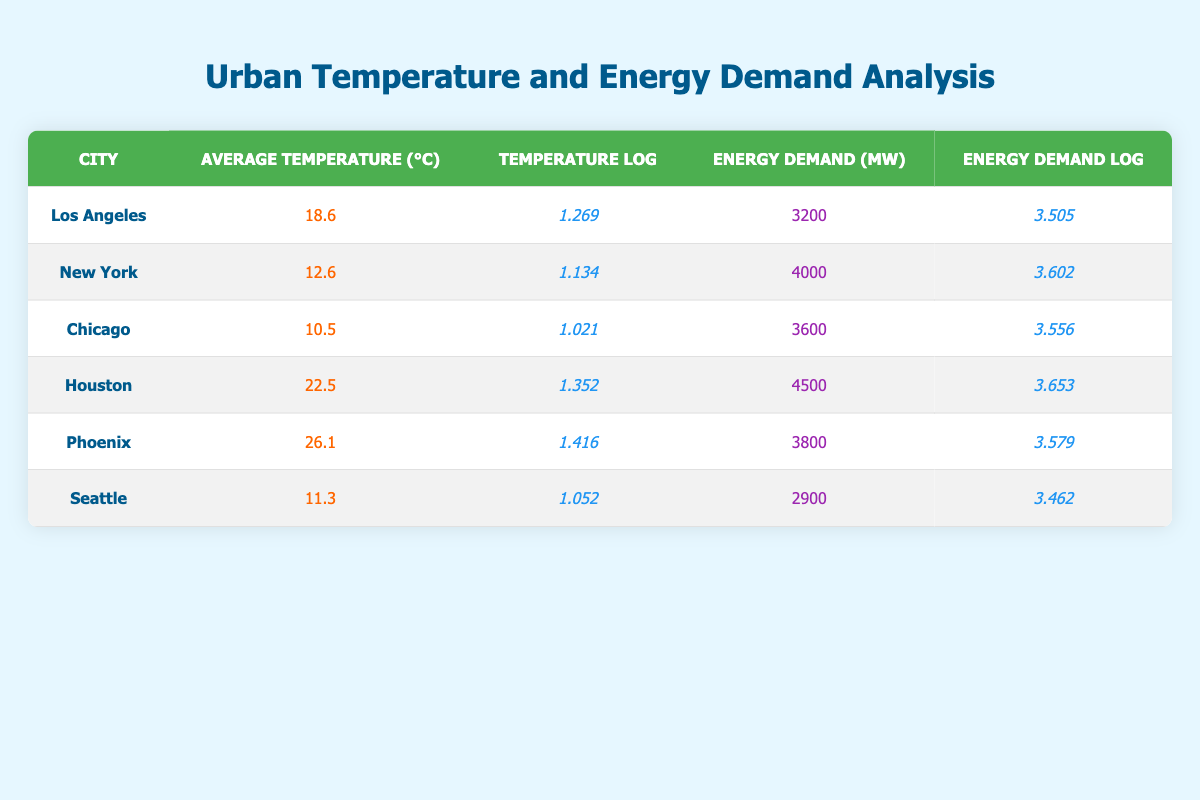What is the average temperature of Houston? The temperature for Houston is listed directly in the table as 22.5 degrees Celsius
Answer: 22.5 Which city has the highest energy demand? By examining the energy demand values, Houston has the highest demand at 4500 MW
Answer: Houston What is the logarithmic value of the average temperature for New York? The table shows that the logarithmic value of the average temperature for New York is 1.134
Answer: 1.134 What is the difference in energy demand between Los Angeles and Seattle? The energy demand for Los Angeles is 3200 MW and for Seattle is 2900 MW. The difference is calculated by subtracting: 3200 - 2900 = 300 MW
Answer: 300 Is the average temperature of Los Angeles higher than that of Seattle? Yes, the average temperature for Los Angeles is 18.6 degrees Celsius, while for Seattle it is 11.3 degrees Celsius
Answer: Yes What is the average energy demand of all the cities listed? The total energy demands are 3200 + 4000 + 3600 + 4500 + 3800 + 2900 = 21800 MW; there are 6 cities, so the average is 21800 / 6 = 3633.33 MW
Answer: 3633.33 In which city does the average temperature have a logarithmic value greater than 1.3? By checking each city's logarithmic temperature value, Houston (1.352) and Phoenix (1.416) are both greater than 1.3
Answer: Houston and Phoenix What is the median average temperature among all the cities? To find the median, list the average temperatures in ascending order: 10.5, 11.3, 12.6, 18.6, 22.5, 26.1. The two middle values are 12.6 and 18.6, so the median is (12.6 + 18.6) / 2 = 15.6 degrees Celsius
Answer: 15.6 Does energy demand decrease consistently with lower average temperatures? No, this is not true since Houston with the highest average temperature (22.5) has the highest energy demand, while Seattle has a lower average temperature (11.3) but a higher demand than some other cities
Answer: No 